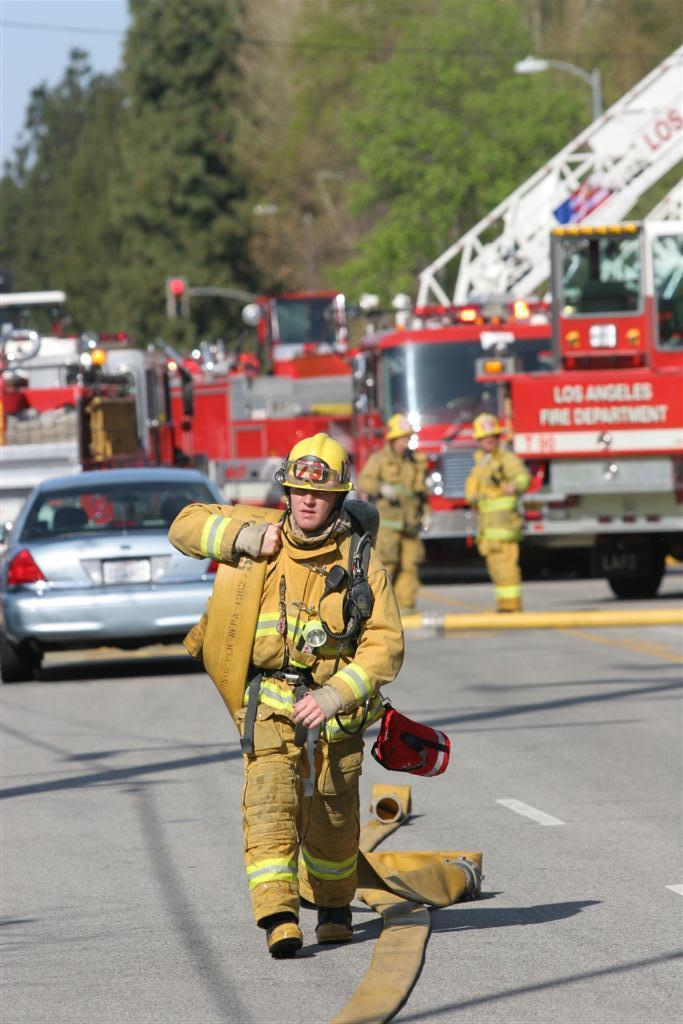<image>
Summarize the visual content of the image. The firefighter from the Los Angeles Fire Department is wearing full gear. 